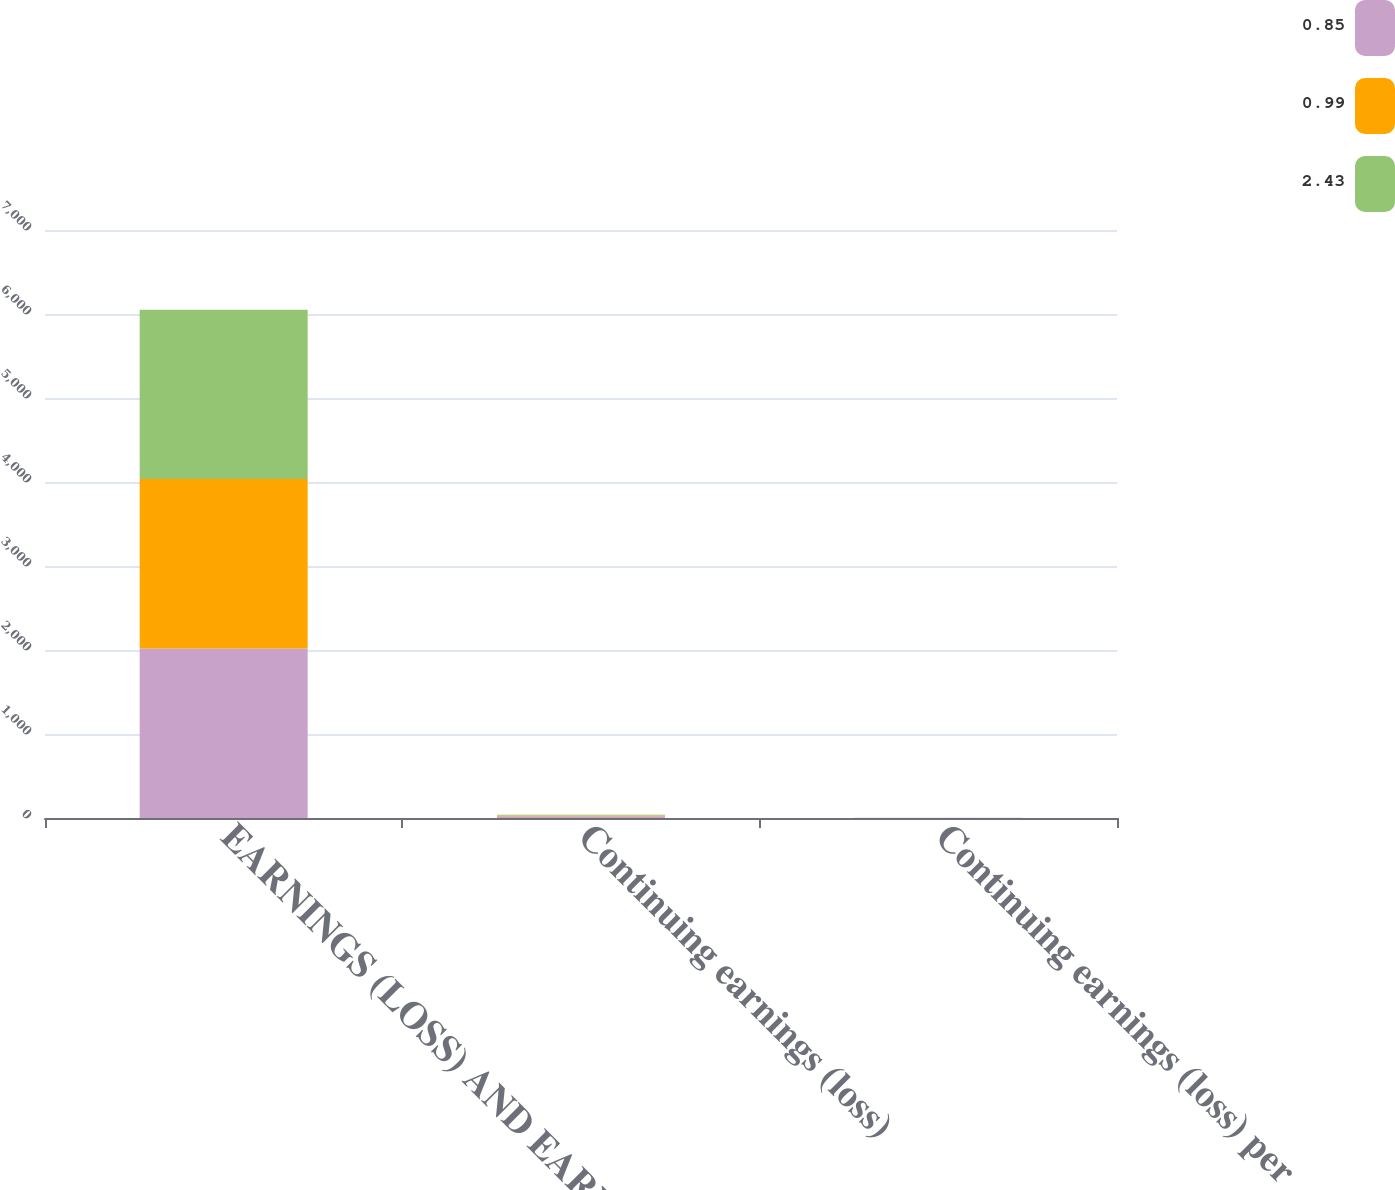Convert chart to OTSL. <chart><loc_0><loc_0><loc_500><loc_500><stacked_bar_chart><ecel><fcel>EARNINGS (LOSS) AND EARNINGS<fcel>Continuing earnings (loss)<fcel>Continuing earnings (loss) per<nl><fcel>0.85<fcel>2018<fcel>21.1<fcel>2.43<nl><fcel>0.99<fcel>2017<fcel>8.6<fcel>0.99<nl><fcel>2.43<fcel>2016<fcel>7.8<fcel>0.85<nl></chart> 